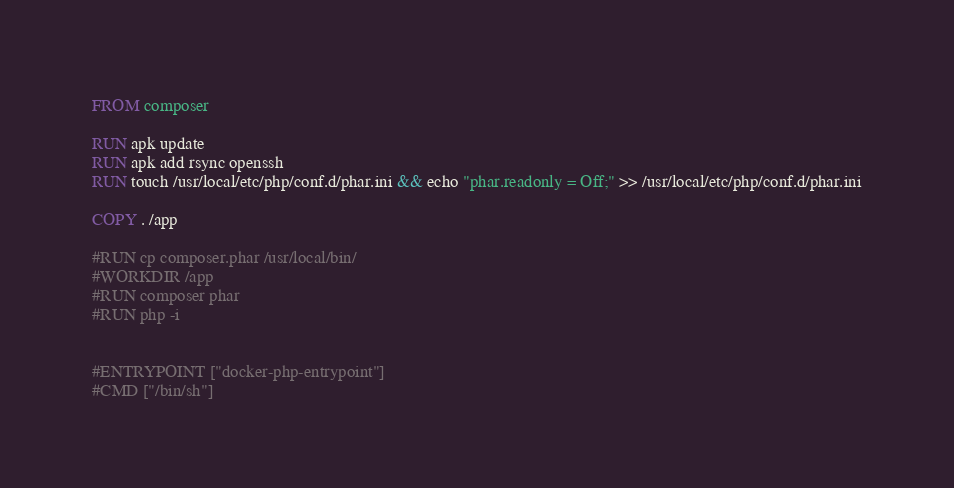<code> <loc_0><loc_0><loc_500><loc_500><_Dockerfile_>FROM composer

RUN apk update
RUN apk add rsync openssh
RUN touch /usr/local/etc/php/conf.d/phar.ini && echo "phar.readonly = Off;" >> /usr/local/etc/php/conf.d/phar.ini

COPY . /app

#RUN cp composer.phar /usr/local/bin/
#WORKDIR /app
#RUN composer phar
#RUN php -i


#ENTRYPOINT ["docker-php-entrypoint"]
#CMD ["/bin/sh"]
</code> 